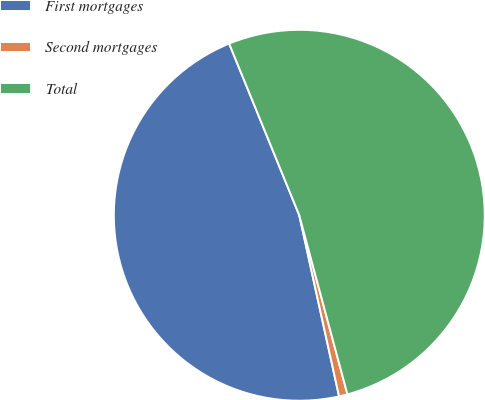Convert chart. <chart><loc_0><loc_0><loc_500><loc_500><pie_chart><fcel>First mortgages<fcel>Second mortgages<fcel>Total<nl><fcel>47.27%<fcel>0.74%<fcel>51.99%<nl></chart> 